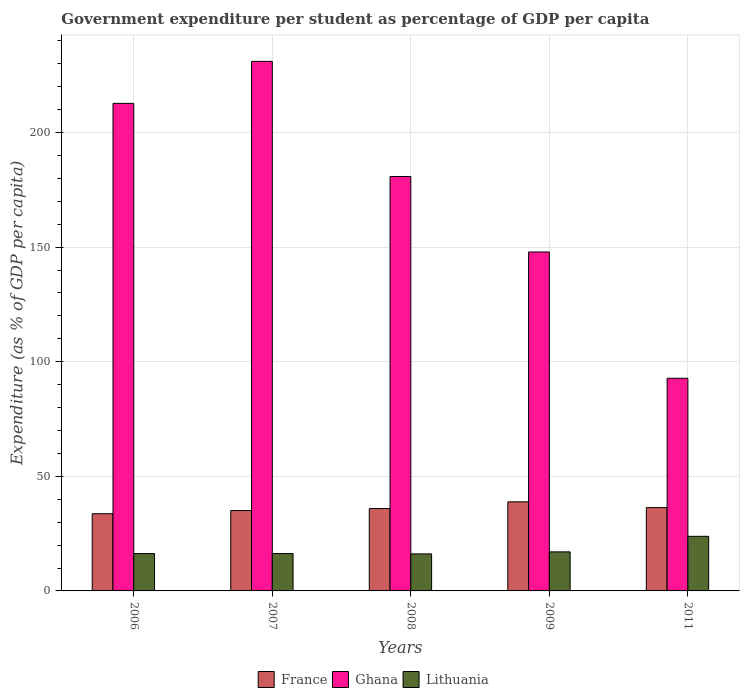How many different coloured bars are there?
Keep it short and to the point. 3. Are the number of bars per tick equal to the number of legend labels?
Provide a succinct answer. Yes. How many bars are there on the 1st tick from the right?
Provide a succinct answer. 3. In how many cases, is the number of bars for a given year not equal to the number of legend labels?
Your answer should be very brief. 0. What is the percentage of expenditure per student in Lithuania in 2008?
Provide a short and direct response. 16.15. Across all years, what is the maximum percentage of expenditure per student in Lithuania?
Ensure brevity in your answer.  23.82. Across all years, what is the minimum percentage of expenditure per student in France?
Give a very brief answer. 33.67. What is the total percentage of expenditure per student in Lithuania in the graph?
Keep it short and to the point. 89.61. What is the difference between the percentage of expenditure per student in Lithuania in 2006 and that in 2011?
Keep it short and to the point. -7.53. What is the difference between the percentage of expenditure per student in Ghana in 2011 and the percentage of expenditure per student in Lithuania in 2009?
Give a very brief answer. 75.74. What is the average percentage of expenditure per student in Ghana per year?
Your answer should be very brief. 173.04. In the year 2007, what is the difference between the percentage of expenditure per student in France and percentage of expenditure per student in Ghana?
Offer a very short reply. -195.96. What is the ratio of the percentage of expenditure per student in Lithuania in 2006 to that in 2011?
Offer a very short reply. 0.68. Is the percentage of expenditure per student in France in 2009 less than that in 2011?
Provide a short and direct response. No. What is the difference between the highest and the second highest percentage of expenditure per student in Lithuania?
Make the answer very short. 6.78. What is the difference between the highest and the lowest percentage of expenditure per student in Ghana?
Your answer should be compact. 138.26. In how many years, is the percentage of expenditure per student in Ghana greater than the average percentage of expenditure per student in Ghana taken over all years?
Offer a very short reply. 3. What does the 1st bar from the left in 2009 represents?
Provide a short and direct response. France. What does the 1st bar from the right in 2008 represents?
Ensure brevity in your answer.  Lithuania. How many bars are there?
Offer a very short reply. 15. How many years are there in the graph?
Give a very brief answer. 5. What is the difference between two consecutive major ticks on the Y-axis?
Make the answer very short. 50. How many legend labels are there?
Keep it short and to the point. 3. What is the title of the graph?
Provide a short and direct response. Government expenditure per student as percentage of GDP per capita. Does "Spain" appear as one of the legend labels in the graph?
Offer a terse response. No. What is the label or title of the Y-axis?
Your answer should be very brief. Expenditure (as % of GDP per capita). What is the Expenditure (as % of GDP per capita) of France in 2006?
Make the answer very short. 33.67. What is the Expenditure (as % of GDP per capita) in Ghana in 2006?
Provide a short and direct response. 212.71. What is the Expenditure (as % of GDP per capita) in Lithuania in 2006?
Your response must be concise. 16.29. What is the Expenditure (as % of GDP per capita) in France in 2007?
Your response must be concise. 35.08. What is the Expenditure (as % of GDP per capita) of Ghana in 2007?
Your answer should be compact. 231.04. What is the Expenditure (as % of GDP per capita) in Lithuania in 2007?
Your answer should be very brief. 16.31. What is the Expenditure (as % of GDP per capita) of France in 2008?
Your answer should be compact. 35.94. What is the Expenditure (as % of GDP per capita) in Ghana in 2008?
Your answer should be very brief. 180.8. What is the Expenditure (as % of GDP per capita) in Lithuania in 2008?
Ensure brevity in your answer.  16.15. What is the Expenditure (as % of GDP per capita) of France in 2009?
Your answer should be compact. 38.87. What is the Expenditure (as % of GDP per capita) of Ghana in 2009?
Your answer should be very brief. 147.88. What is the Expenditure (as % of GDP per capita) of Lithuania in 2009?
Give a very brief answer. 17.04. What is the Expenditure (as % of GDP per capita) in France in 2011?
Give a very brief answer. 36.35. What is the Expenditure (as % of GDP per capita) in Ghana in 2011?
Give a very brief answer. 92.78. What is the Expenditure (as % of GDP per capita) in Lithuania in 2011?
Provide a short and direct response. 23.82. Across all years, what is the maximum Expenditure (as % of GDP per capita) of France?
Your response must be concise. 38.87. Across all years, what is the maximum Expenditure (as % of GDP per capita) in Ghana?
Ensure brevity in your answer.  231.04. Across all years, what is the maximum Expenditure (as % of GDP per capita) in Lithuania?
Provide a succinct answer. 23.82. Across all years, what is the minimum Expenditure (as % of GDP per capita) of France?
Offer a very short reply. 33.67. Across all years, what is the minimum Expenditure (as % of GDP per capita) of Ghana?
Provide a short and direct response. 92.78. Across all years, what is the minimum Expenditure (as % of GDP per capita) in Lithuania?
Offer a very short reply. 16.15. What is the total Expenditure (as % of GDP per capita) in France in the graph?
Give a very brief answer. 179.91. What is the total Expenditure (as % of GDP per capita) in Ghana in the graph?
Ensure brevity in your answer.  865.22. What is the total Expenditure (as % of GDP per capita) in Lithuania in the graph?
Make the answer very short. 89.61. What is the difference between the Expenditure (as % of GDP per capita) in France in 2006 and that in 2007?
Your answer should be compact. -1.41. What is the difference between the Expenditure (as % of GDP per capita) of Ghana in 2006 and that in 2007?
Provide a short and direct response. -18.33. What is the difference between the Expenditure (as % of GDP per capita) in Lithuania in 2006 and that in 2007?
Your answer should be very brief. -0.02. What is the difference between the Expenditure (as % of GDP per capita) of France in 2006 and that in 2008?
Offer a very short reply. -2.27. What is the difference between the Expenditure (as % of GDP per capita) of Ghana in 2006 and that in 2008?
Your answer should be compact. 31.91. What is the difference between the Expenditure (as % of GDP per capita) of Lithuania in 2006 and that in 2008?
Offer a very short reply. 0.14. What is the difference between the Expenditure (as % of GDP per capita) in France in 2006 and that in 2009?
Give a very brief answer. -5.19. What is the difference between the Expenditure (as % of GDP per capita) in Ghana in 2006 and that in 2009?
Your response must be concise. 64.83. What is the difference between the Expenditure (as % of GDP per capita) of Lithuania in 2006 and that in 2009?
Your response must be concise. -0.75. What is the difference between the Expenditure (as % of GDP per capita) of France in 2006 and that in 2011?
Provide a succinct answer. -2.68. What is the difference between the Expenditure (as % of GDP per capita) in Ghana in 2006 and that in 2011?
Keep it short and to the point. 119.92. What is the difference between the Expenditure (as % of GDP per capita) of Lithuania in 2006 and that in 2011?
Provide a short and direct response. -7.53. What is the difference between the Expenditure (as % of GDP per capita) of France in 2007 and that in 2008?
Offer a very short reply. -0.86. What is the difference between the Expenditure (as % of GDP per capita) in Ghana in 2007 and that in 2008?
Offer a very short reply. 50.24. What is the difference between the Expenditure (as % of GDP per capita) in Lithuania in 2007 and that in 2008?
Your response must be concise. 0.16. What is the difference between the Expenditure (as % of GDP per capita) of France in 2007 and that in 2009?
Offer a very short reply. -3.79. What is the difference between the Expenditure (as % of GDP per capita) of Ghana in 2007 and that in 2009?
Provide a short and direct response. 83.17. What is the difference between the Expenditure (as % of GDP per capita) in Lithuania in 2007 and that in 2009?
Your answer should be very brief. -0.73. What is the difference between the Expenditure (as % of GDP per capita) of France in 2007 and that in 2011?
Provide a short and direct response. -1.27. What is the difference between the Expenditure (as % of GDP per capita) of Ghana in 2007 and that in 2011?
Keep it short and to the point. 138.26. What is the difference between the Expenditure (as % of GDP per capita) in Lithuania in 2007 and that in 2011?
Offer a very short reply. -7.51. What is the difference between the Expenditure (as % of GDP per capita) in France in 2008 and that in 2009?
Offer a very short reply. -2.92. What is the difference between the Expenditure (as % of GDP per capita) of Ghana in 2008 and that in 2009?
Provide a succinct answer. 32.93. What is the difference between the Expenditure (as % of GDP per capita) in Lithuania in 2008 and that in 2009?
Your response must be concise. -0.89. What is the difference between the Expenditure (as % of GDP per capita) in France in 2008 and that in 2011?
Provide a succinct answer. -0.41. What is the difference between the Expenditure (as % of GDP per capita) of Ghana in 2008 and that in 2011?
Your response must be concise. 88.02. What is the difference between the Expenditure (as % of GDP per capita) in Lithuania in 2008 and that in 2011?
Offer a very short reply. -7.67. What is the difference between the Expenditure (as % of GDP per capita) in France in 2009 and that in 2011?
Your answer should be very brief. 2.51. What is the difference between the Expenditure (as % of GDP per capita) in Ghana in 2009 and that in 2011?
Your answer should be compact. 55.09. What is the difference between the Expenditure (as % of GDP per capita) of Lithuania in 2009 and that in 2011?
Provide a short and direct response. -6.78. What is the difference between the Expenditure (as % of GDP per capita) of France in 2006 and the Expenditure (as % of GDP per capita) of Ghana in 2007?
Make the answer very short. -197.37. What is the difference between the Expenditure (as % of GDP per capita) of France in 2006 and the Expenditure (as % of GDP per capita) of Lithuania in 2007?
Give a very brief answer. 17.37. What is the difference between the Expenditure (as % of GDP per capita) of Ghana in 2006 and the Expenditure (as % of GDP per capita) of Lithuania in 2007?
Keep it short and to the point. 196.4. What is the difference between the Expenditure (as % of GDP per capita) of France in 2006 and the Expenditure (as % of GDP per capita) of Ghana in 2008?
Offer a terse response. -147.13. What is the difference between the Expenditure (as % of GDP per capita) of France in 2006 and the Expenditure (as % of GDP per capita) of Lithuania in 2008?
Ensure brevity in your answer.  17.52. What is the difference between the Expenditure (as % of GDP per capita) in Ghana in 2006 and the Expenditure (as % of GDP per capita) in Lithuania in 2008?
Your answer should be very brief. 196.56. What is the difference between the Expenditure (as % of GDP per capita) in France in 2006 and the Expenditure (as % of GDP per capita) in Ghana in 2009?
Your answer should be compact. -114.2. What is the difference between the Expenditure (as % of GDP per capita) of France in 2006 and the Expenditure (as % of GDP per capita) of Lithuania in 2009?
Your answer should be compact. 16.63. What is the difference between the Expenditure (as % of GDP per capita) in Ghana in 2006 and the Expenditure (as % of GDP per capita) in Lithuania in 2009?
Provide a short and direct response. 195.67. What is the difference between the Expenditure (as % of GDP per capita) of France in 2006 and the Expenditure (as % of GDP per capita) of Ghana in 2011?
Ensure brevity in your answer.  -59.11. What is the difference between the Expenditure (as % of GDP per capita) in France in 2006 and the Expenditure (as % of GDP per capita) in Lithuania in 2011?
Provide a short and direct response. 9.85. What is the difference between the Expenditure (as % of GDP per capita) of Ghana in 2006 and the Expenditure (as % of GDP per capita) of Lithuania in 2011?
Your answer should be very brief. 188.89. What is the difference between the Expenditure (as % of GDP per capita) of France in 2007 and the Expenditure (as % of GDP per capita) of Ghana in 2008?
Provide a short and direct response. -145.72. What is the difference between the Expenditure (as % of GDP per capita) in France in 2007 and the Expenditure (as % of GDP per capita) in Lithuania in 2008?
Your answer should be compact. 18.93. What is the difference between the Expenditure (as % of GDP per capita) in Ghana in 2007 and the Expenditure (as % of GDP per capita) in Lithuania in 2008?
Ensure brevity in your answer.  214.89. What is the difference between the Expenditure (as % of GDP per capita) of France in 2007 and the Expenditure (as % of GDP per capita) of Ghana in 2009?
Provide a succinct answer. -112.8. What is the difference between the Expenditure (as % of GDP per capita) of France in 2007 and the Expenditure (as % of GDP per capita) of Lithuania in 2009?
Make the answer very short. 18.04. What is the difference between the Expenditure (as % of GDP per capita) of Ghana in 2007 and the Expenditure (as % of GDP per capita) of Lithuania in 2009?
Make the answer very short. 214. What is the difference between the Expenditure (as % of GDP per capita) in France in 2007 and the Expenditure (as % of GDP per capita) in Ghana in 2011?
Offer a terse response. -57.71. What is the difference between the Expenditure (as % of GDP per capita) in France in 2007 and the Expenditure (as % of GDP per capita) in Lithuania in 2011?
Ensure brevity in your answer.  11.26. What is the difference between the Expenditure (as % of GDP per capita) in Ghana in 2007 and the Expenditure (as % of GDP per capita) in Lithuania in 2011?
Ensure brevity in your answer.  207.22. What is the difference between the Expenditure (as % of GDP per capita) of France in 2008 and the Expenditure (as % of GDP per capita) of Ghana in 2009?
Your answer should be very brief. -111.93. What is the difference between the Expenditure (as % of GDP per capita) in France in 2008 and the Expenditure (as % of GDP per capita) in Lithuania in 2009?
Offer a very short reply. 18.9. What is the difference between the Expenditure (as % of GDP per capita) in Ghana in 2008 and the Expenditure (as % of GDP per capita) in Lithuania in 2009?
Your response must be concise. 163.76. What is the difference between the Expenditure (as % of GDP per capita) of France in 2008 and the Expenditure (as % of GDP per capita) of Ghana in 2011?
Your answer should be compact. -56.84. What is the difference between the Expenditure (as % of GDP per capita) of France in 2008 and the Expenditure (as % of GDP per capita) of Lithuania in 2011?
Ensure brevity in your answer.  12.12. What is the difference between the Expenditure (as % of GDP per capita) in Ghana in 2008 and the Expenditure (as % of GDP per capita) in Lithuania in 2011?
Offer a terse response. 156.98. What is the difference between the Expenditure (as % of GDP per capita) in France in 2009 and the Expenditure (as % of GDP per capita) in Ghana in 2011?
Your answer should be very brief. -53.92. What is the difference between the Expenditure (as % of GDP per capita) of France in 2009 and the Expenditure (as % of GDP per capita) of Lithuania in 2011?
Keep it short and to the point. 15.05. What is the difference between the Expenditure (as % of GDP per capita) of Ghana in 2009 and the Expenditure (as % of GDP per capita) of Lithuania in 2011?
Give a very brief answer. 124.06. What is the average Expenditure (as % of GDP per capita) of France per year?
Give a very brief answer. 35.98. What is the average Expenditure (as % of GDP per capita) of Ghana per year?
Your response must be concise. 173.04. What is the average Expenditure (as % of GDP per capita) of Lithuania per year?
Your answer should be compact. 17.92. In the year 2006, what is the difference between the Expenditure (as % of GDP per capita) in France and Expenditure (as % of GDP per capita) in Ghana?
Keep it short and to the point. -179.04. In the year 2006, what is the difference between the Expenditure (as % of GDP per capita) of France and Expenditure (as % of GDP per capita) of Lithuania?
Provide a short and direct response. 17.39. In the year 2006, what is the difference between the Expenditure (as % of GDP per capita) in Ghana and Expenditure (as % of GDP per capita) in Lithuania?
Ensure brevity in your answer.  196.42. In the year 2007, what is the difference between the Expenditure (as % of GDP per capita) of France and Expenditure (as % of GDP per capita) of Ghana?
Provide a short and direct response. -195.96. In the year 2007, what is the difference between the Expenditure (as % of GDP per capita) of France and Expenditure (as % of GDP per capita) of Lithuania?
Offer a very short reply. 18.77. In the year 2007, what is the difference between the Expenditure (as % of GDP per capita) in Ghana and Expenditure (as % of GDP per capita) in Lithuania?
Your answer should be very brief. 214.74. In the year 2008, what is the difference between the Expenditure (as % of GDP per capita) of France and Expenditure (as % of GDP per capita) of Ghana?
Make the answer very short. -144.86. In the year 2008, what is the difference between the Expenditure (as % of GDP per capita) of France and Expenditure (as % of GDP per capita) of Lithuania?
Keep it short and to the point. 19.79. In the year 2008, what is the difference between the Expenditure (as % of GDP per capita) of Ghana and Expenditure (as % of GDP per capita) of Lithuania?
Ensure brevity in your answer.  164.65. In the year 2009, what is the difference between the Expenditure (as % of GDP per capita) in France and Expenditure (as % of GDP per capita) in Ghana?
Give a very brief answer. -109.01. In the year 2009, what is the difference between the Expenditure (as % of GDP per capita) in France and Expenditure (as % of GDP per capita) in Lithuania?
Offer a very short reply. 21.82. In the year 2009, what is the difference between the Expenditure (as % of GDP per capita) of Ghana and Expenditure (as % of GDP per capita) of Lithuania?
Make the answer very short. 130.84. In the year 2011, what is the difference between the Expenditure (as % of GDP per capita) in France and Expenditure (as % of GDP per capita) in Ghana?
Give a very brief answer. -56.43. In the year 2011, what is the difference between the Expenditure (as % of GDP per capita) of France and Expenditure (as % of GDP per capita) of Lithuania?
Offer a very short reply. 12.53. In the year 2011, what is the difference between the Expenditure (as % of GDP per capita) of Ghana and Expenditure (as % of GDP per capita) of Lithuania?
Your answer should be very brief. 68.97. What is the ratio of the Expenditure (as % of GDP per capita) in France in 2006 to that in 2007?
Your response must be concise. 0.96. What is the ratio of the Expenditure (as % of GDP per capita) of Ghana in 2006 to that in 2007?
Provide a short and direct response. 0.92. What is the ratio of the Expenditure (as % of GDP per capita) of France in 2006 to that in 2008?
Offer a very short reply. 0.94. What is the ratio of the Expenditure (as % of GDP per capita) in Ghana in 2006 to that in 2008?
Your answer should be very brief. 1.18. What is the ratio of the Expenditure (as % of GDP per capita) of Lithuania in 2006 to that in 2008?
Provide a succinct answer. 1.01. What is the ratio of the Expenditure (as % of GDP per capita) in France in 2006 to that in 2009?
Ensure brevity in your answer.  0.87. What is the ratio of the Expenditure (as % of GDP per capita) of Ghana in 2006 to that in 2009?
Make the answer very short. 1.44. What is the ratio of the Expenditure (as % of GDP per capita) in Lithuania in 2006 to that in 2009?
Provide a succinct answer. 0.96. What is the ratio of the Expenditure (as % of GDP per capita) in France in 2006 to that in 2011?
Your answer should be compact. 0.93. What is the ratio of the Expenditure (as % of GDP per capita) of Ghana in 2006 to that in 2011?
Provide a short and direct response. 2.29. What is the ratio of the Expenditure (as % of GDP per capita) of Lithuania in 2006 to that in 2011?
Ensure brevity in your answer.  0.68. What is the ratio of the Expenditure (as % of GDP per capita) in France in 2007 to that in 2008?
Your answer should be very brief. 0.98. What is the ratio of the Expenditure (as % of GDP per capita) of Ghana in 2007 to that in 2008?
Give a very brief answer. 1.28. What is the ratio of the Expenditure (as % of GDP per capita) of Lithuania in 2007 to that in 2008?
Offer a very short reply. 1.01. What is the ratio of the Expenditure (as % of GDP per capita) of France in 2007 to that in 2009?
Provide a short and direct response. 0.9. What is the ratio of the Expenditure (as % of GDP per capita) in Ghana in 2007 to that in 2009?
Provide a succinct answer. 1.56. What is the ratio of the Expenditure (as % of GDP per capita) in Lithuania in 2007 to that in 2009?
Provide a succinct answer. 0.96. What is the ratio of the Expenditure (as % of GDP per capita) in Ghana in 2007 to that in 2011?
Keep it short and to the point. 2.49. What is the ratio of the Expenditure (as % of GDP per capita) in Lithuania in 2007 to that in 2011?
Provide a short and direct response. 0.68. What is the ratio of the Expenditure (as % of GDP per capita) of France in 2008 to that in 2009?
Make the answer very short. 0.92. What is the ratio of the Expenditure (as % of GDP per capita) of Ghana in 2008 to that in 2009?
Provide a short and direct response. 1.22. What is the ratio of the Expenditure (as % of GDP per capita) of Lithuania in 2008 to that in 2009?
Ensure brevity in your answer.  0.95. What is the ratio of the Expenditure (as % of GDP per capita) of France in 2008 to that in 2011?
Offer a very short reply. 0.99. What is the ratio of the Expenditure (as % of GDP per capita) of Ghana in 2008 to that in 2011?
Keep it short and to the point. 1.95. What is the ratio of the Expenditure (as % of GDP per capita) of Lithuania in 2008 to that in 2011?
Keep it short and to the point. 0.68. What is the ratio of the Expenditure (as % of GDP per capita) in France in 2009 to that in 2011?
Give a very brief answer. 1.07. What is the ratio of the Expenditure (as % of GDP per capita) in Ghana in 2009 to that in 2011?
Your answer should be very brief. 1.59. What is the ratio of the Expenditure (as % of GDP per capita) in Lithuania in 2009 to that in 2011?
Keep it short and to the point. 0.72. What is the difference between the highest and the second highest Expenditure (as % of GDP per capita) in France?
Your answer should be very brief. 2.51. What is the difference between the highest and the second highest Expenditure (as % of GDP per capita) of Ghana?
Keep it short and to the point. 18.33. What is the difference between the highest and the second highest Expenditure (as % of GDP per capita) in Lithuania?
Provide a succinct answer. 6.78. What is the difference between the highest and the lowest Expenditure (as % of GDP per capita) of France?
Ensure brevity in your answer.  5.19. What is the difference between the highest and the lowest Expenditure (as % of GDP per capita) in Ghana?
Offer a very short reply. 138.26. What is the difference between the highest and the lowest Expenditure (as % of GDP per capita) of Lithuania?
Make the answer very short. 7.67. 